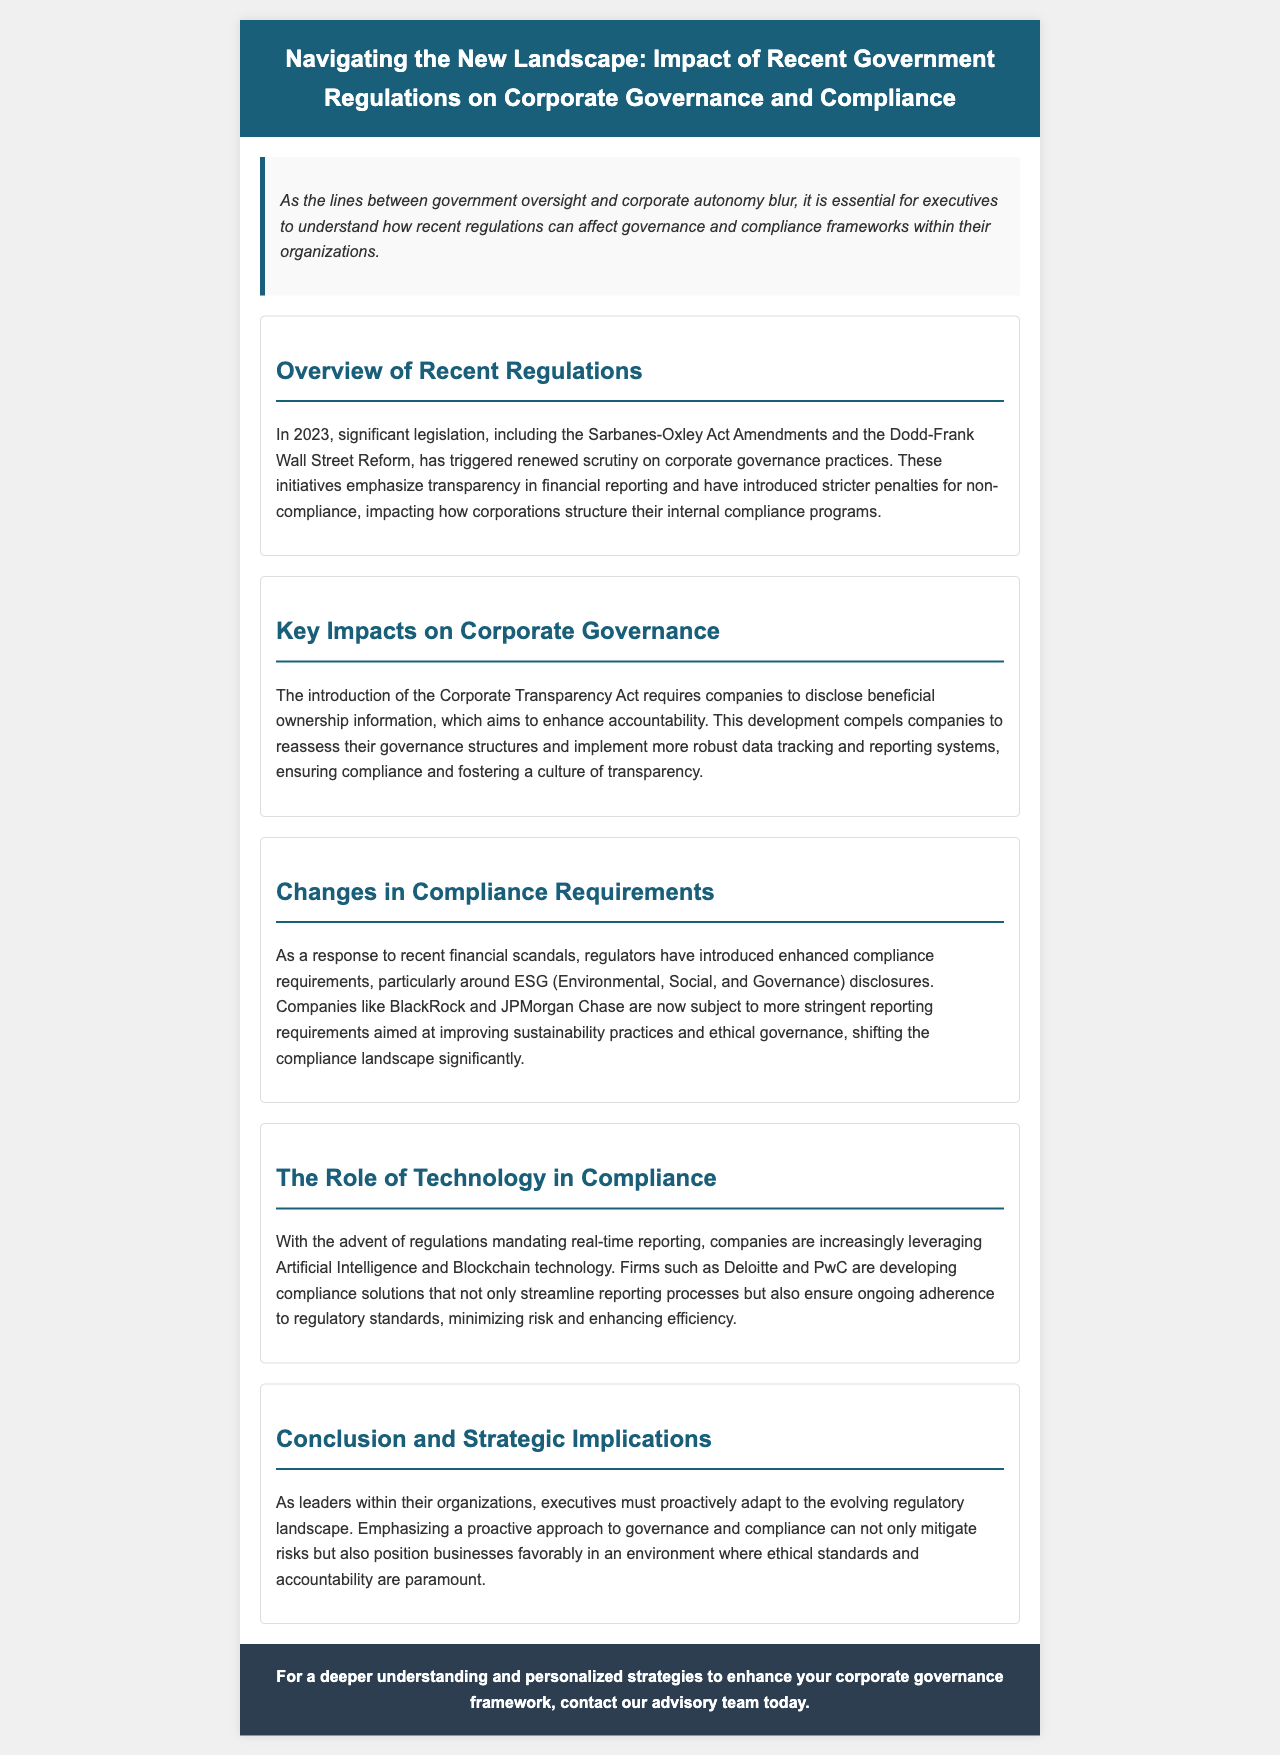What significant legislation was mentioned? The document refers to the Sarbanes-Oxley Act Amendments and the Dodd-Frank Wall Street Reform as significant legislation impacting corporate governance.
Answer: Sarbanes-Oxley Act Amendments and Dodd-Frank Wall Street Reform What does the Corporate Transparency Act require? The Corporate Transparency Act mandates companies to disclose beneficial ownership information to enhance accountability.
Answer: Disclosure of beneficial ownership information Which companies are subject to enhanced compliance requirements? The document specifically mentions BlackRock and JPMorgan Chase as companies subject to more stringent reporting requirements.
Answer: BlackRock and JPMorgan Chase What technology is mentioned as being leveraged for compliance? The newsletter highlights the use of Artificial Intelligence and Blockchain technology in enhancing compliance processes.
Answer: Artificial Intelligence and Blockchain technology What is the main focus of the conclusion? The conclusion emphasizes the importance of a proactive approach to governance and compliance to mitigate risks.
Answer: Proactive approach to governance and compliance How do recent regulations affect internal compliance programs? The regulations introduce stricter penalties for non-compliance, affecting how corporations structure their internal compliance programs.
Answer: Stricter penalties for non-compliance 